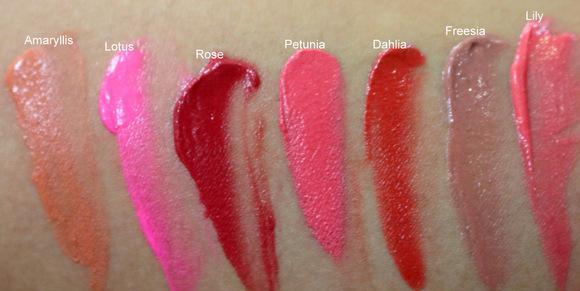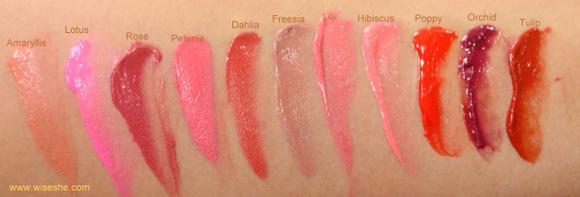The first image is the image on the left, the second image is the image on the right. Considering the images on both sides, is "One arm has 4 swatches on it." valid? Answer yes or no. No. The first image is the image on the left, the second image is the image on the right. For the images displayed, is the sentence "Each image shows lipstick stripe marks on pale skin displayed vertically, and each image includes at least five different stripes of color." factually correct? Answer yes or no. Yes. 